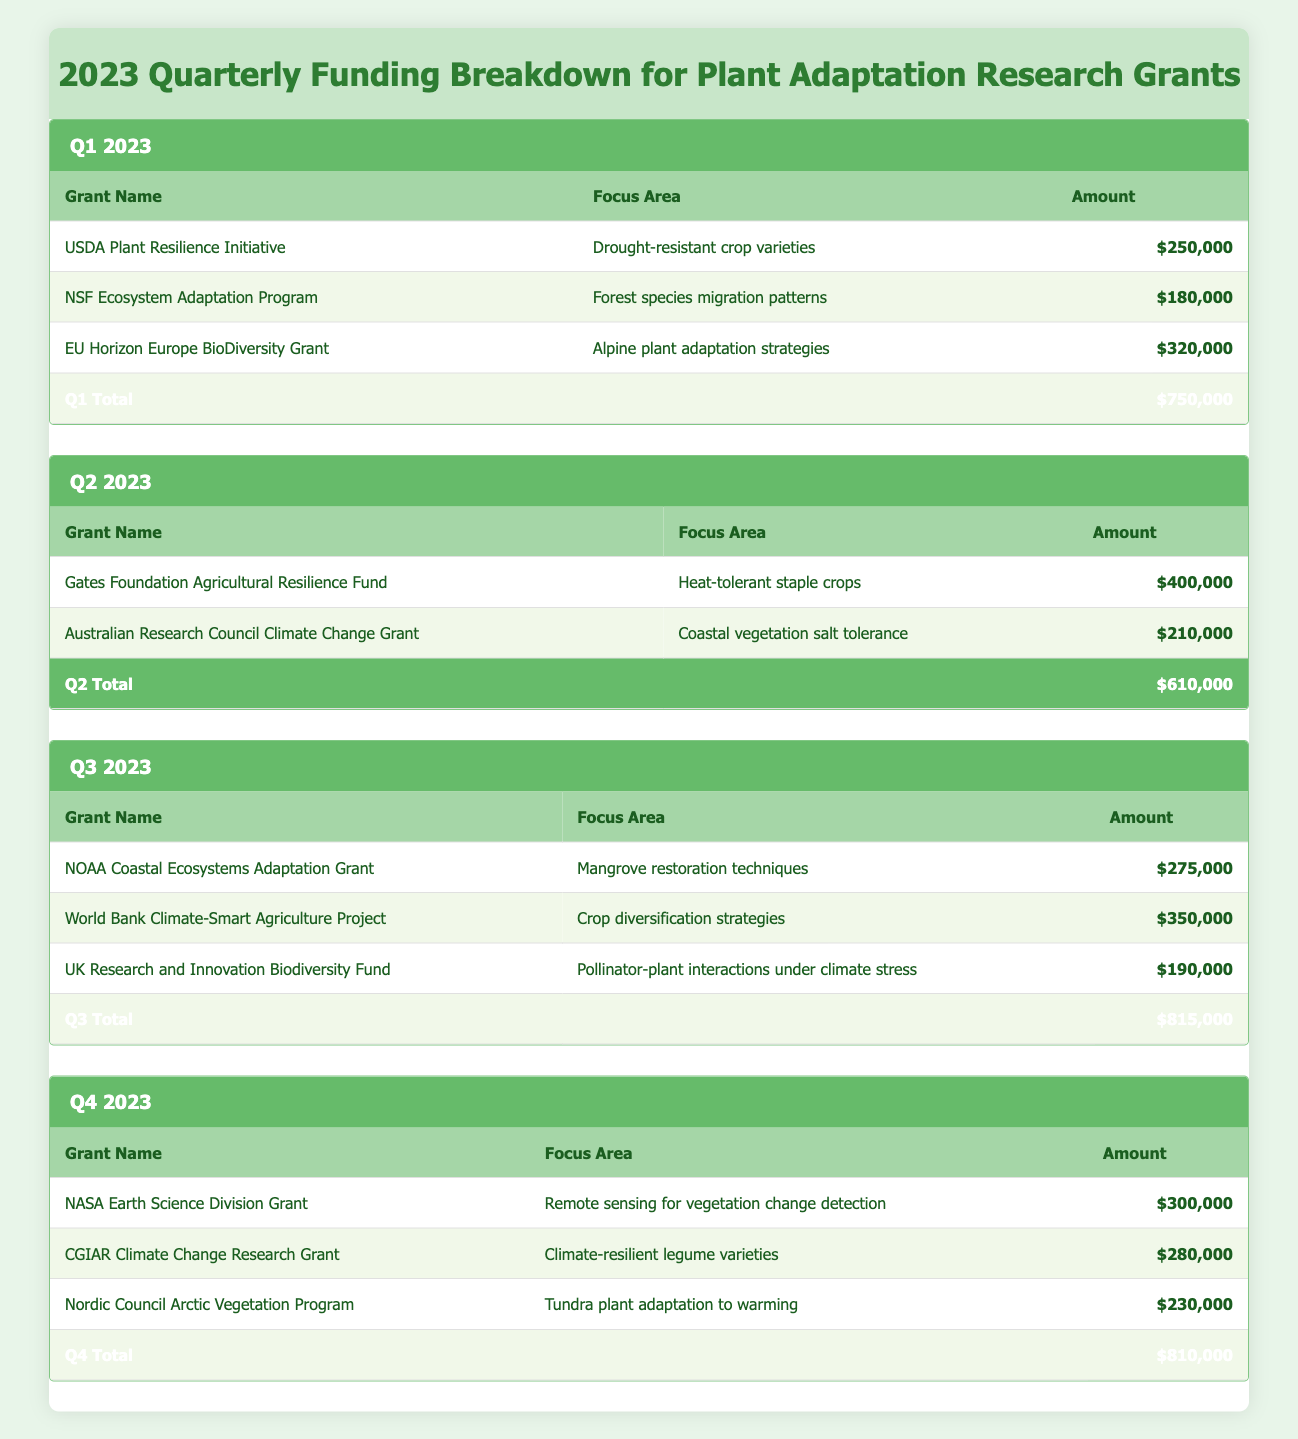What is the total funding for Q1 2023? The Q1 total funding is listed in the table under the Q1 section, where it states that the total is $750,000.
Answer: 750,000 Which grant focused on drought-resistant crop varieties? The USDA Plant Resilience Initiative focuses on drought-resistant crop varieties and is listed in the Q1 section with an amount of $250,000.
Answer: USDA Plant Resilience Initiative What was the average grant amount in Q3 2023? To find the average grant amount, sum the amounts for each grant in Q3: 275,000 + 350,000 + 190,000 = 815,000. Then divide by the number of grants: 815,000 / 3 = 271,666.67.
Answer: 271,666.67 Is the Gates Foundation grant larger than the total for Q2? The Gates Foundation Agricultural Resilience Fund is $400,000, while the total funding for Q2 is $610,000. Since 400,000 is less than 610,000, the answer is no.
Answer: No How much more funding was allocated to Q2 than to Q1? Q2 funding is $610,000 and Q1 funding is $750,000. The difference is calculated as: 610,000 - 750,000 = -140,000, showing Q2 received less funding than Q1.
Answer: -140,000 What was the total funding for all quarters combined in 2023? Add the total funding from all quarters: Q1 ($750,000) + Q2 ($610,000) + Q3 ($815,000) + Q4 ($810,000) = 750,000 + 610,000 + 815,000 + 810,000 = 2,985,000.
Answer: 2,985,000 Did any quarter receive exactly $600,000 in funding? Looking through the totals for each quarter, Q1 has $750,000, Q2 has $610,000, Q3 has $815,000, and Q4 has $810,000. Since none are exactly $600,000, the answer is no.
Answer: No Which focus area received the highest amount of funding? The highest individual grant was the Gates Foundation Agricultural Resilience Fund in Q2, which received $400,000, making it the largest single grant.
Answer: Heat-tolerant staple crops 